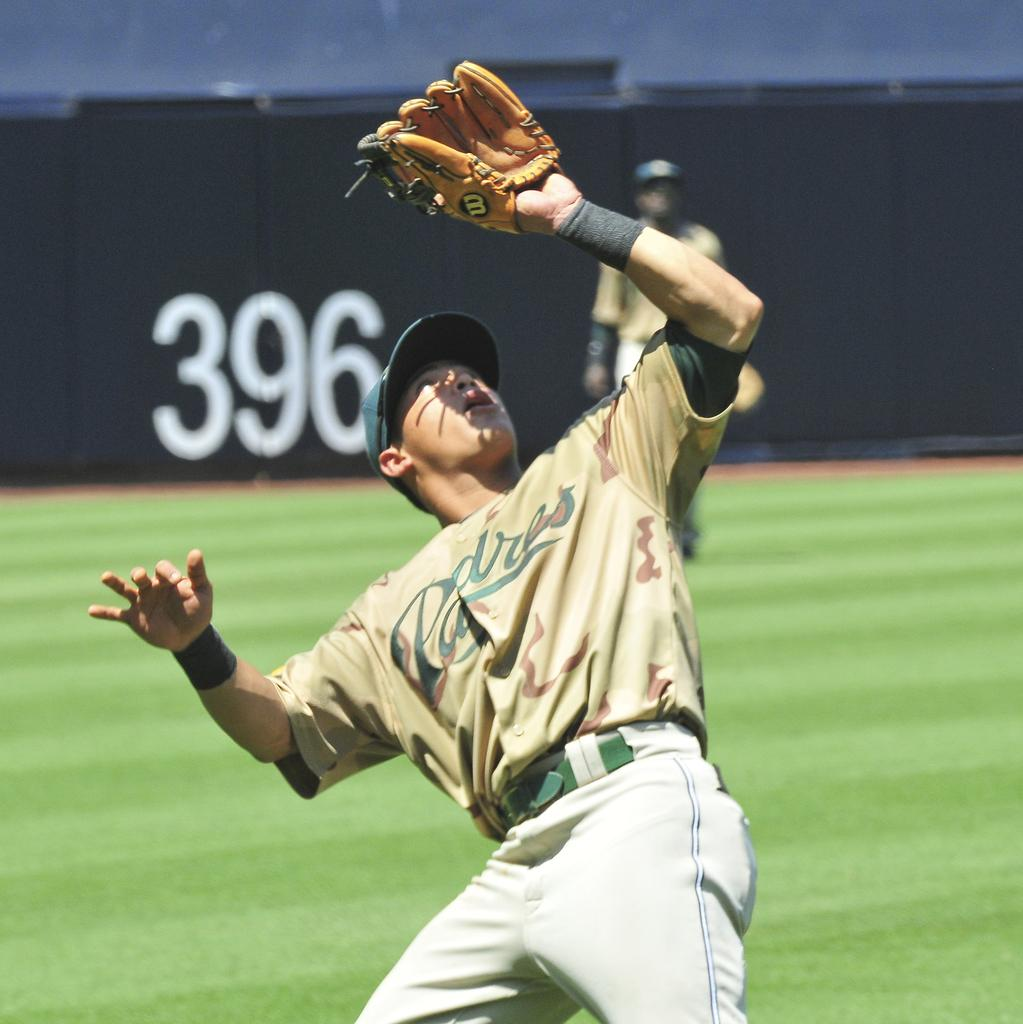<image>
Render a clear and concise summary of the photo. padres player looking up into sun trying to catch ball and outfield wall shows it is 396 feet at back 